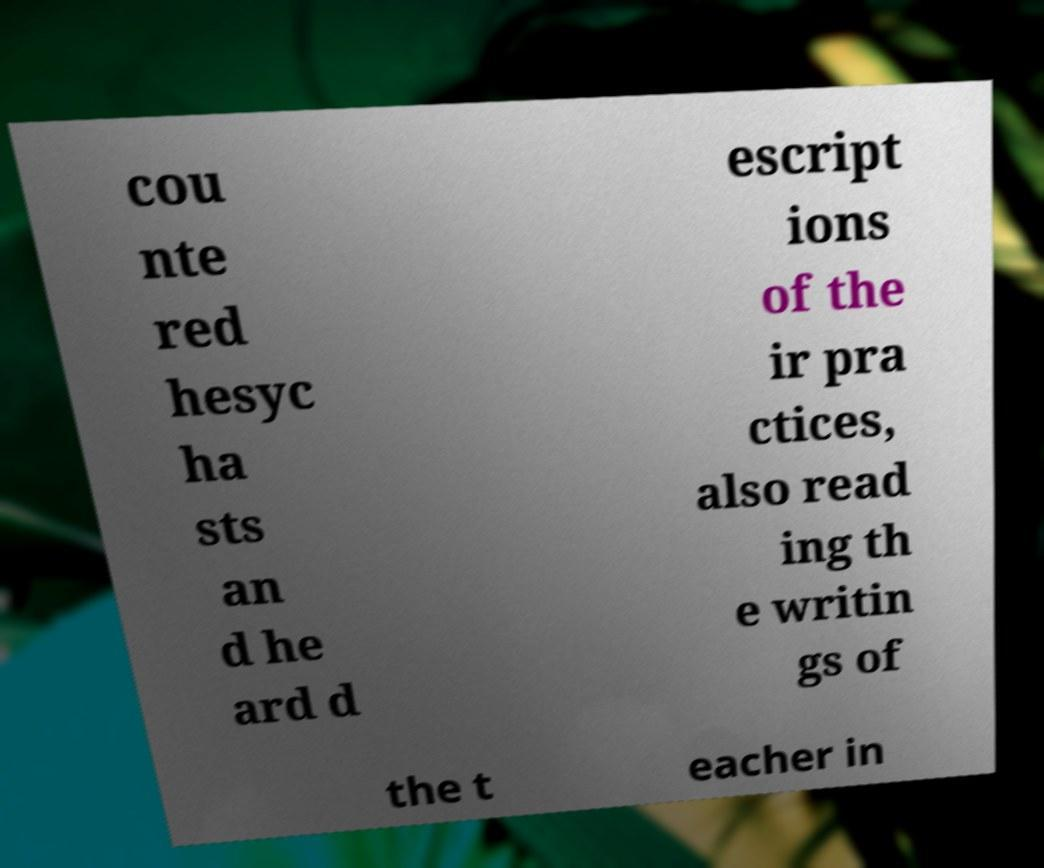For documentation purposes, I need the text within this image transcribed. Could you provide that? cou nte red hesyc ha sts an d he ard d escript ions of the ir pra ctices, also read ing th e writin gs of the t eacher in 